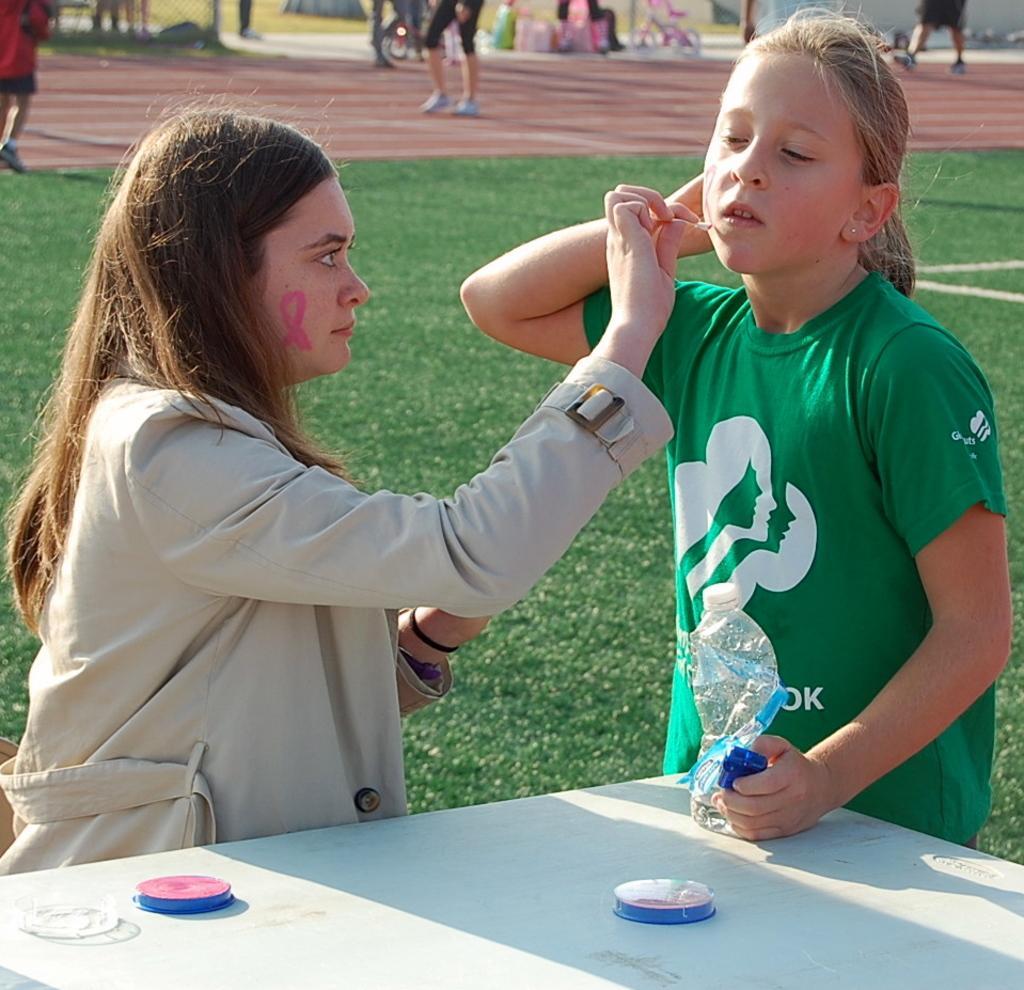Can you describe this image briefly? In this picture there is a woman sitting and painting. There is a girl standing and holding the bottle and there are objects on the table. At the back there are group of people walking and there is a bicycle and there are bags and there is a fence. At the bottom there is grass. 